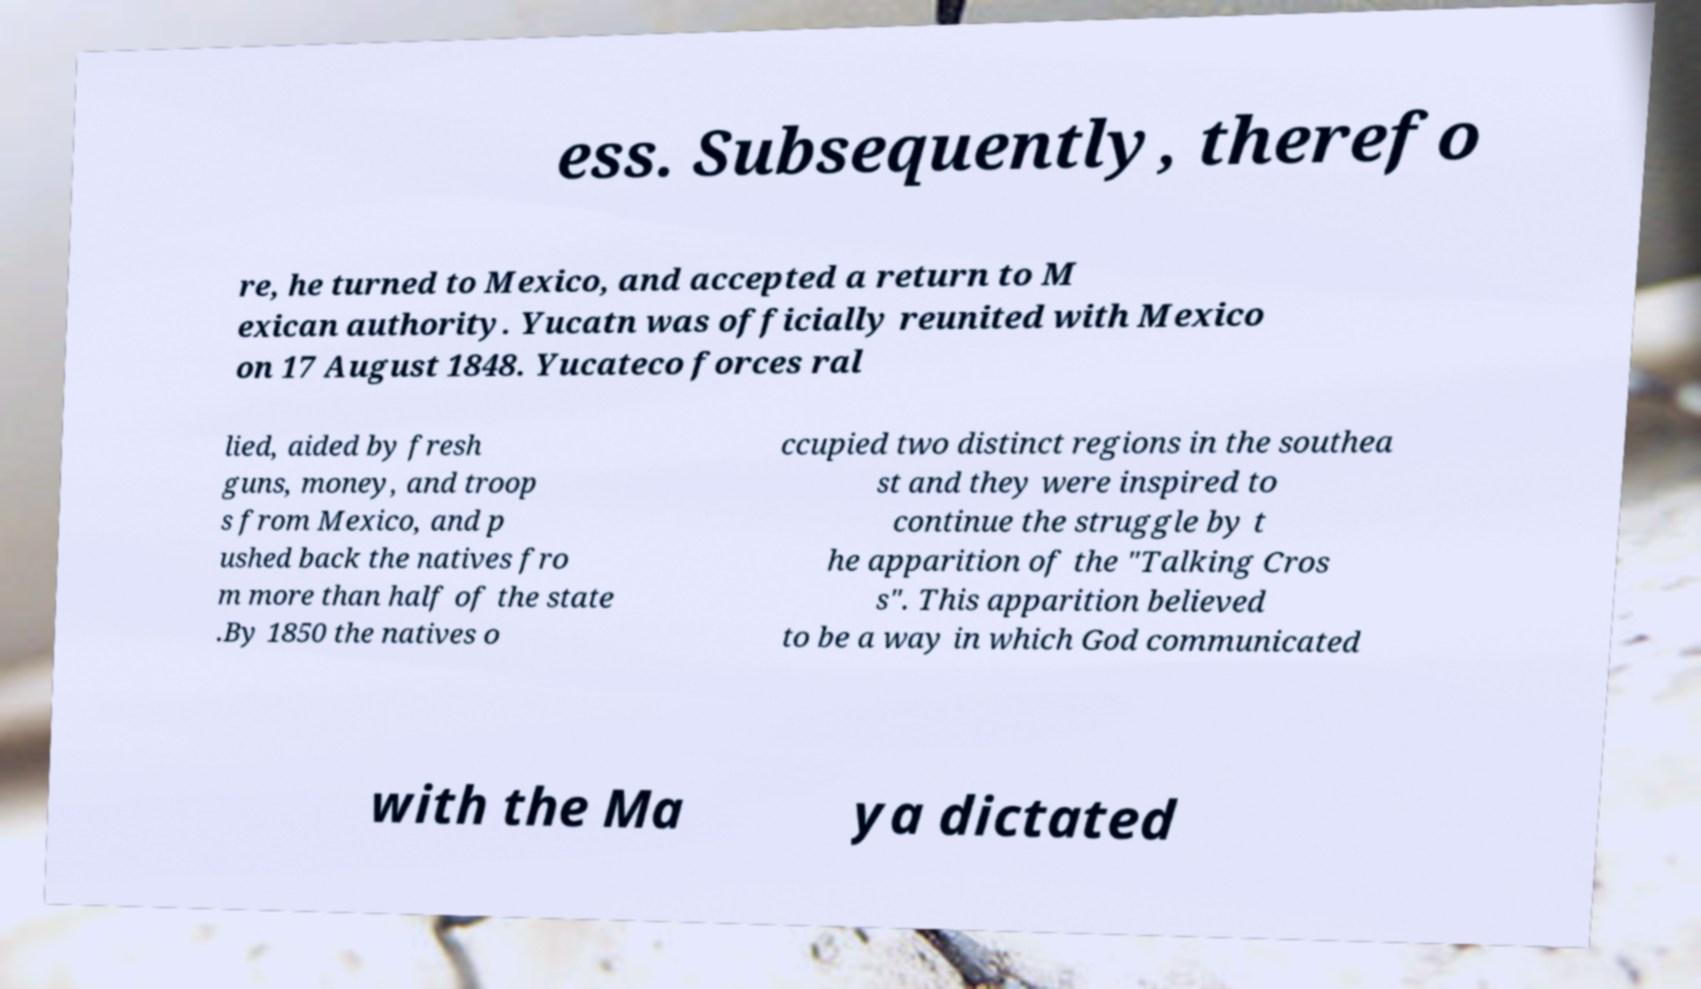There's text embedded in this image that I need extracted. Can you transcribe it verbatim? ess. Subsequently, therefo re, he turned to Mexico, and accepted a return to M exican authority. Yucatn was officially reunited with Mexico on 17 August 1848. Yucateco forces ral lied, aided by fresh guns, money, and troop s from Mexico, and p ushed back the natives fro m more than half of the state .By 1850 the natives o ccupied two distinct regions in the southea st and they were inspired to continue the struggle by t he apparition of the "Talking Cros s". This apparition believed to be a way in which God communicated with the Ma ya dictated 